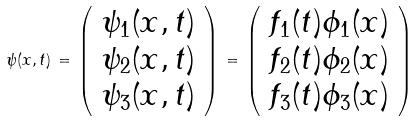<formula> <loc_0><loc_0><loc_500><loc_500>\psi ( x , t ) \, = \, \left ( \begin{array} { c } { { \psi _ { 1 } ( x , t ) } } \\ { { \psi _ { 2 } ( x , t ) } } \\ { { \psi _ { 3 } ( x , t ) } } \end{array} \right ) \, = \, \left ( \begin{array} { c } { { f _ { 1 } ( t ) \phi _ { 1 } ( x ) } } \\ { { f _ { 2 } ( t ) \phi _ { 2 } ( x ) } } \\ { { f _ { 3 } ( t ) \phi _ { 3 } ( x ) } } \end{array} \right )</formula> 